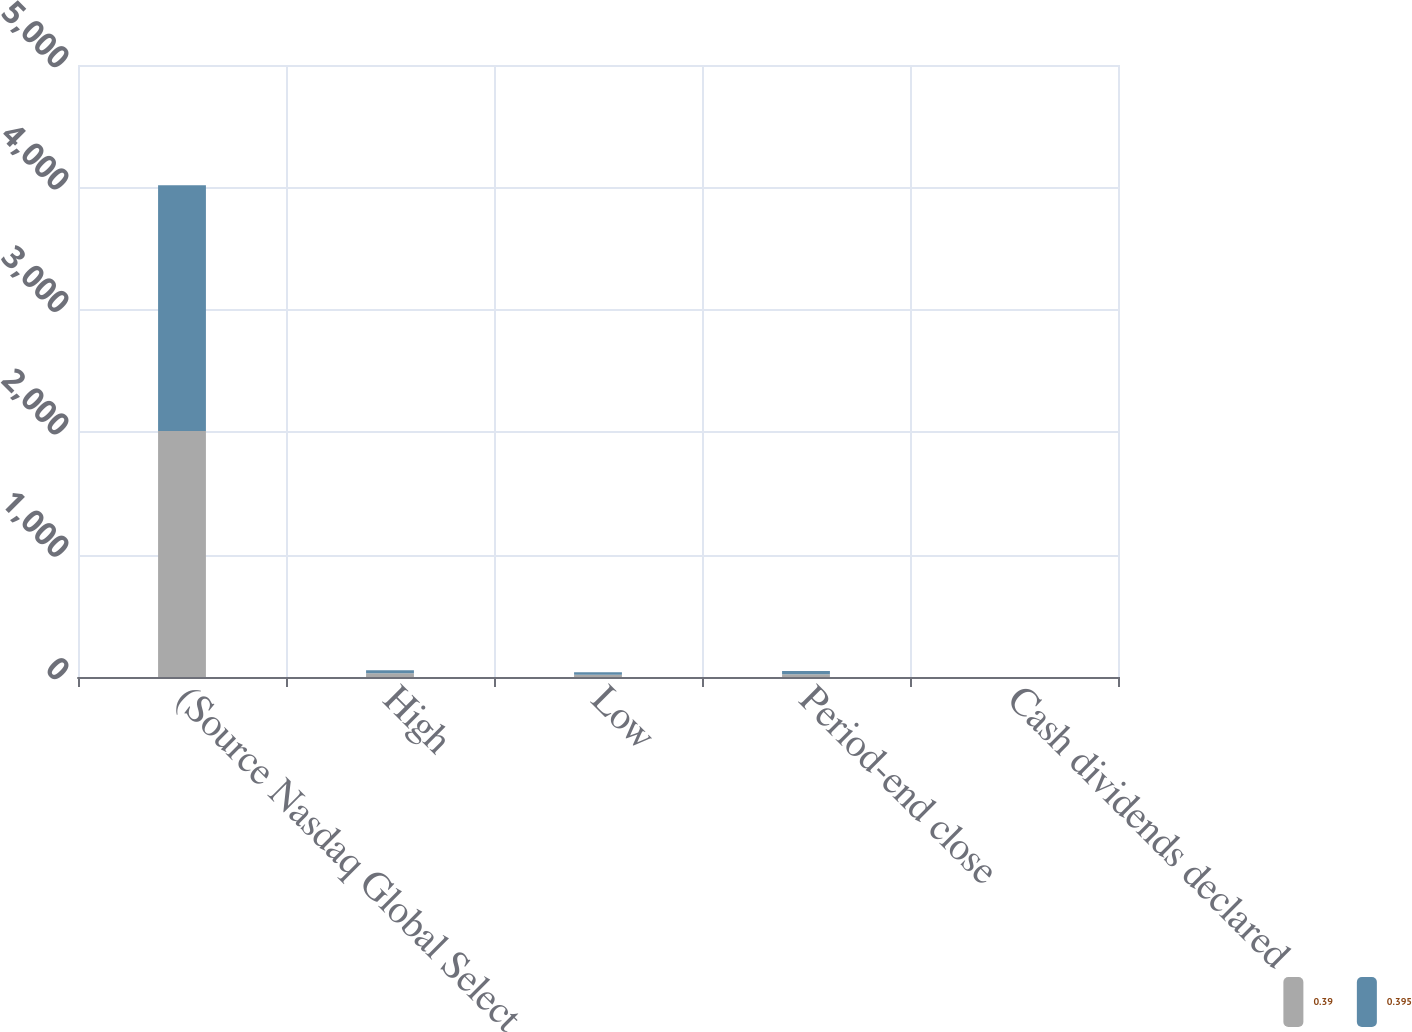Convert chart. <chart><loc_0><loc_0><loc_500><loc_500><stacked_bar_chart><ecel><fcel>(Source Nasdaq Global Select<fcel>High<fcel>Low<fcel>Period-end close<fcel>Cash dividends declared<nl><fcel>0.39<fcel>2009<fcel>29.66<fcel>17.84<fcel>22.87<fcel>0.39<nl><fcel>0.395<fcel>2009<fcel>26.31<fcel>21.3<fcel>25.99<fcel>0.4<nl></chart> 